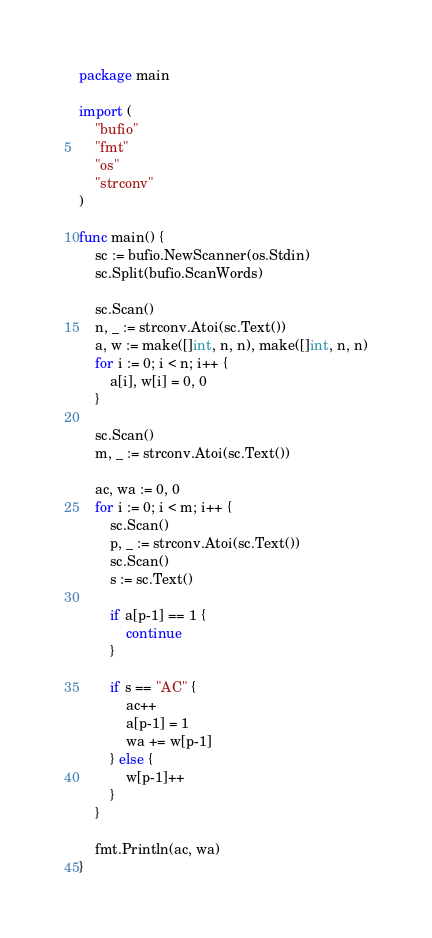Convert code to text. <code><loc_0><loc_0><loc_500><loc_500><_Go_>package main

import (
	"bufio"
	"fmt"
	"os"
	"strconv"
)

func main() {
	sc := bufio.NewScanner(os.Stdin)
	sc.Split(bufio.ScanWords)

	sc.Scan()
	n, _ := strconv.Atoi(sc.Text())
	a, w := make([]int, n, n), make([]int, n, n)
	for i := 0; i < n; i++ {
		a[i], w[i] = 0, 0
	}

	sc.Scan()
	m, _ := strconv.Atoi(sc.Text())

	ac, wa := 0, 0
	for i := 0; i < m; i++ {
		sc.Scan()
		p, _ := strconv.Atoi(sc.Text())
		sc.Scan()
		s := sc.Text()

		if a[p-1] == 1 {
			continue
		}

		if s == "AC" {
			ac++
			a[p-1] = 1
			wa += w[p-1]
		} else {
			w[p-1]++
		}
	}

	fmt.Println(ac, wa)
}
</code> 